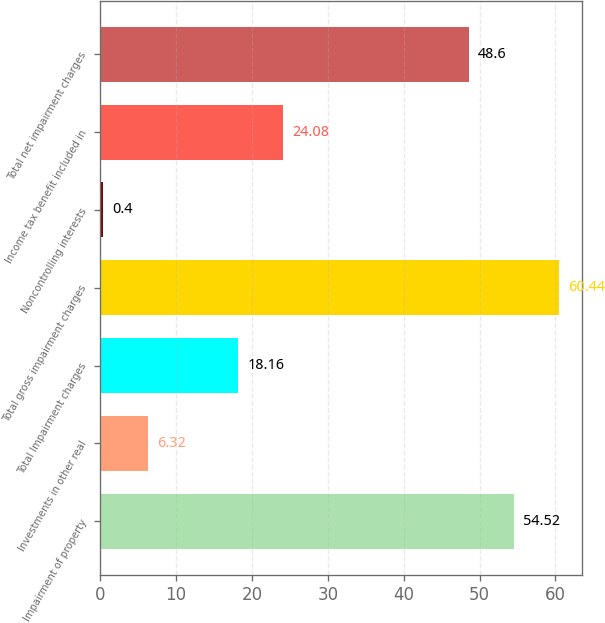<chart> <loc_0><loc_0><loc_500><loc_500><bar_chart><fcel>Impairment of property<fcel>Investments in other real<fcel>Total Impairment charges<fcel>Total gross impairment charges<fcel>Noncontrolling interests<fcel>Income tax benefit included in<fcel>Total net impairment charges<nl><fcel>54.52<fcel>6.32<fcel>18.16<fcel>60.44<fcel>0.4<fcel>24.08<fcel>48.6<nl></chart> 